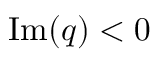Convert formula to latex. <formula><loc_0><loc_0><loc_500><loc_500>{ I m } ( q ) < 0</formula> 